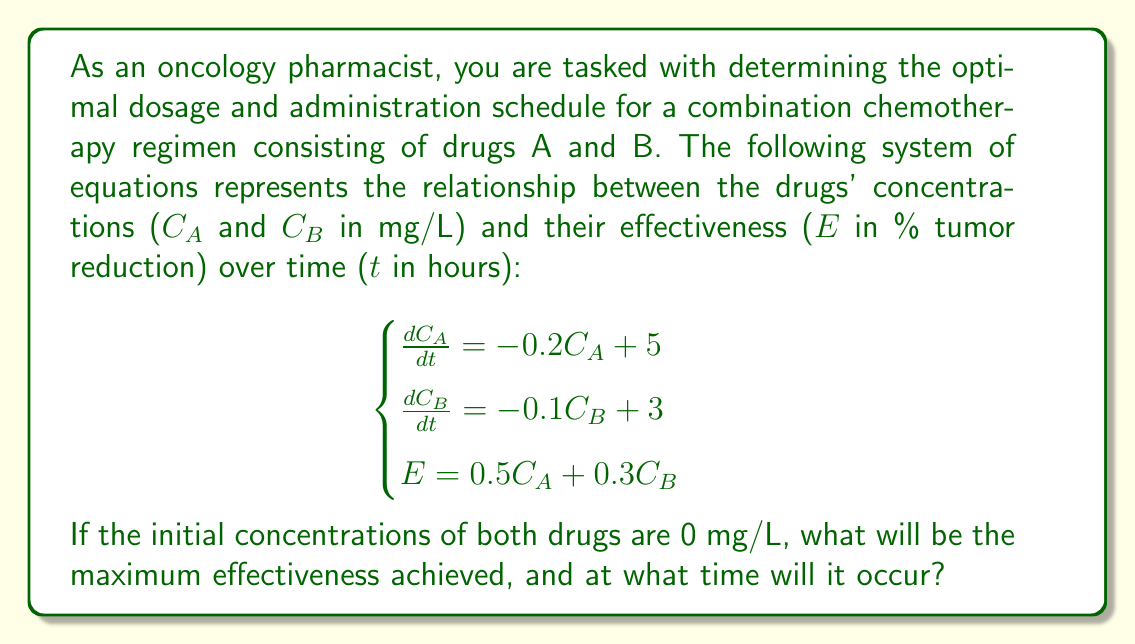What is the answer to this math problem? To solve this problem, we need to follow these steps:

1. Solve the differential equations for $C_A$ and $C_B$.
2. Substitute the solutions into the effectiveness equation.
3. Find the maximum of the effectiveness function.

Step 1: Solving the differential equations

For drug A: $\frac{dC_A}{dt} = -0.2C_A + 5$
This is a first-order linear differential equation. The solution is:
$C_A(t) = 25(1 - e^{-0.2t})$

For drug B: $\frac{dC_B}{dt} = -0.1C_B + 3$
Similarly, the solution is:
$C_B(t) = 30(1 - e^{-0.1t})$

Step 2: Substituting into the effectiveness equation

$E(t) = 0.5C_A(t) + 0.3C_B(t)$
$E(t) = 0.5[25(1 - e^{-0.2t})] + 0.3[30(1 - e^{-0.1t})]$
$E(t) = 12.5(1 - e^{-0.2t}) + 9(1 - e^{-0.1t})$
$E(t) = 21.5 - 12.5e^{-0.2t} - 9e^{-0.1t}$

Step 3: Finding the maximum effectiveness

To find the maximum, we need to differentiate $E(t)$ with respect to $t$ and set it to zero:

$\frac{dE}{dt} = 2.5e^{-0.2t} + 0.9e^{-0.1t}$

Setting this equal to zero:

$2.5e^{-0.2t} + 0.9e^{-0.1t} = 0$

This equation cannot be solved analytically. We need to use numerical methods to find the solution. Using a computer algebra system or numerical solver, we find that the maximum occurs at approximately $t = 11.78$ hours.

Substituting this value back into the effectiveness equation:

$E(11.78) = 21.5 - 12.5e^{-0.2(11.78)} - 9e^{-0.1(11.78)} \approx 18.95$

Therefore, the maximum effectiveness is approximately 18.95% tumor reduction, occurring at about 11.78 hours after administration.
Answer: The maximum effectiveness achieved is approximately 18.95% tumor reduction, occurring at approximately 11.78 hours after administration. 